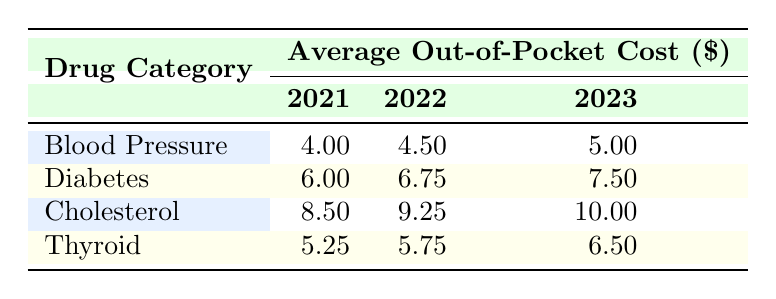What was the average out-of-pocket cost for Blood Pressure medications in 2023? The table shows that the average out-of-pocket cost for Blood Pressure medications in 2023 is 5.00.
Answer: 5.00 How much did Diabetes medications cost out-of-pocket on average in 2022? The table lists the out-of-pocket costs for Diabetes medications in 2022, which is 6.75.
Answer: 6.75 What is the difference in average out-of-pocket costs for Cholesterol medications between 2021 and 2023? The average out-of-pocket cost for Cholesterol medications in 2021 is 8.50, and in 2023 it is 10.00. The difference is 10.00 - 8.50 = 1.50.
Answer: 1.50 Did the out-of-pocket expenses for Thyroid medications increase from 2021 to 2023? In 2021, the out-of-pocket cost for Thyroid medications was 5.25, and in 2023 it increased to 6.50. Therefore, the expenses did increase.
Answer: Yes Which drug category had the highest average out-of-pocket cost in 2022? By examining the table, the Cholesterol category has the highest average out-of-pocket cost in 2022 at 9.25 compared to Blood Pressure (4.50), Diabetes (6.75), and Thyroid (5.75).
Answer: Cholesterol What was the average out-of-pocket cost for all drug categories in 2021? First, sum the average out-of-pocket costs: Blood Pressure (4.00) + Diabetes (6.00) + Cholesterol (8.50) + Thyroid (5.25) = 23.75. Then, divide by the number of categories (4): 23.75 / 4 = 5.9375. Rounding gives approximately 5.94.
Answer: 5.94 Is it true that the out-of-pocket cost for Atorvastatin decreased from 2022 to 2021? The out-of-pocket cost for Atorvastatin in 2021 is 8.50, while in 2022 it increased to 9.25. Thus, it did not decrease.
Answer: No What was the overall trend in average out-of-pocket costs for Diabetes medications from 2021 to 2023? The average out-of-pocket cost for Diabetes medications increased from 6.00 in 2021 to 6.75 in 2022 and then to 7.50 in 2023. Therefore, the trend indicates an increase over these years.
Answer: Increasing 